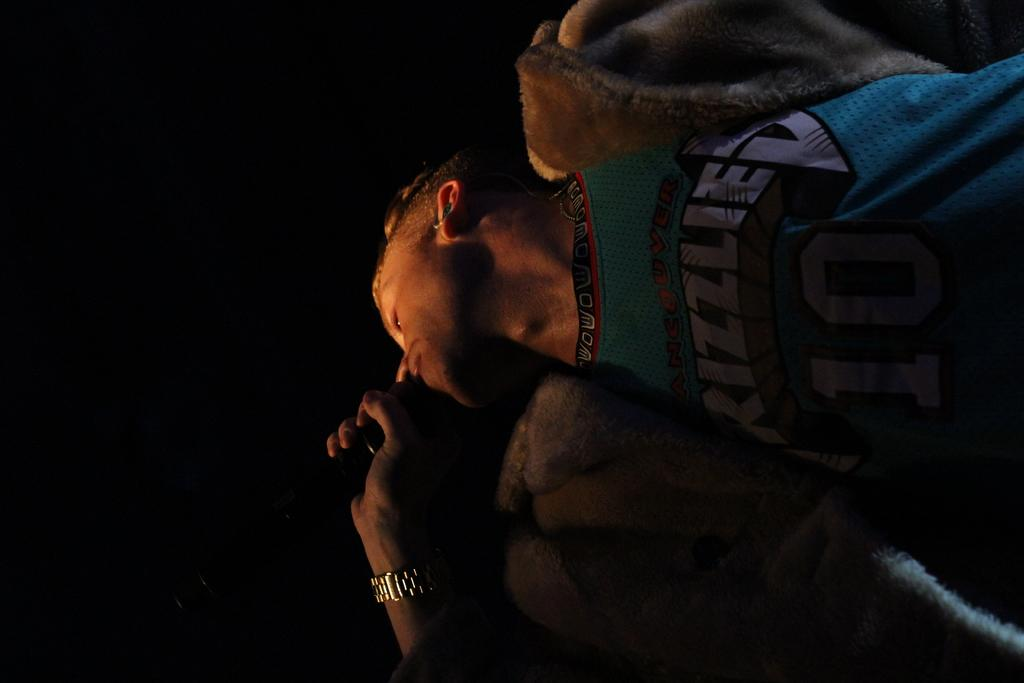Who is the main subject in the image? There is a man in the image. What is the man holding in his hand? The man is holding a microphone in his hand. Can you describe any accessories the man is wearing? The man is wearing a watch. What is the color of the background in the image? The background of the image is dark. What type of cloud can be seen in the image? There is no cloud present in the image. Can you tell me where the library is located in the image? There is no library present in the image. 